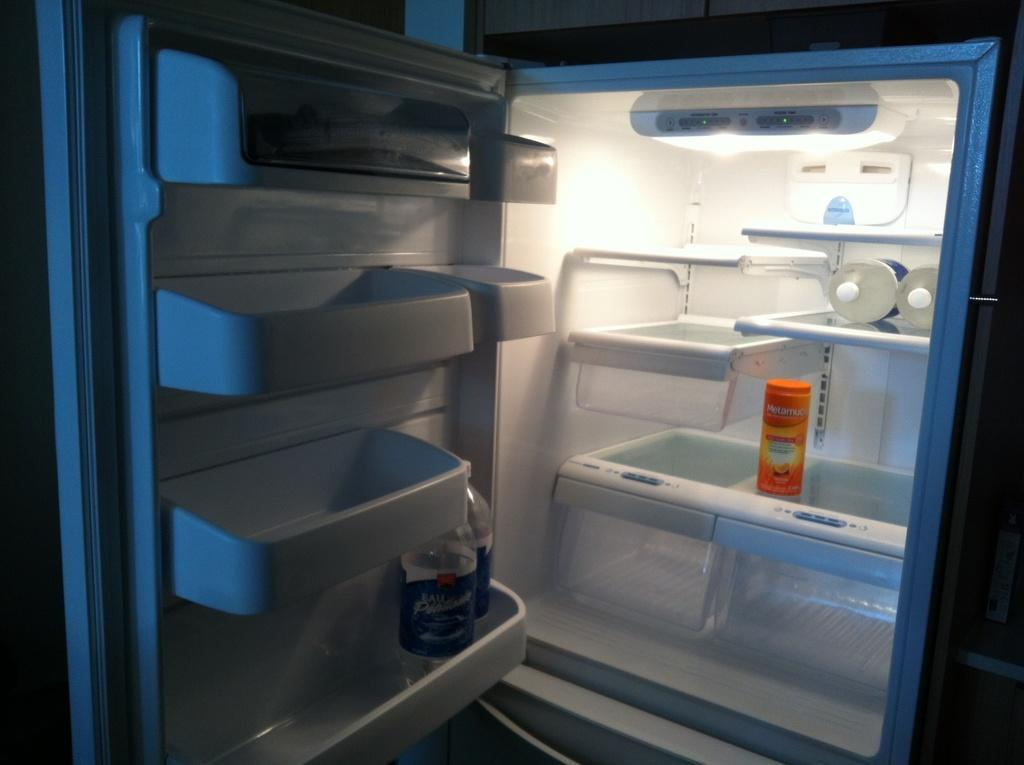Provide a one-sentence caption for the provided image. The door of a refrigerator is open, with just a few bottles of water and a container of Metamucil inside. 